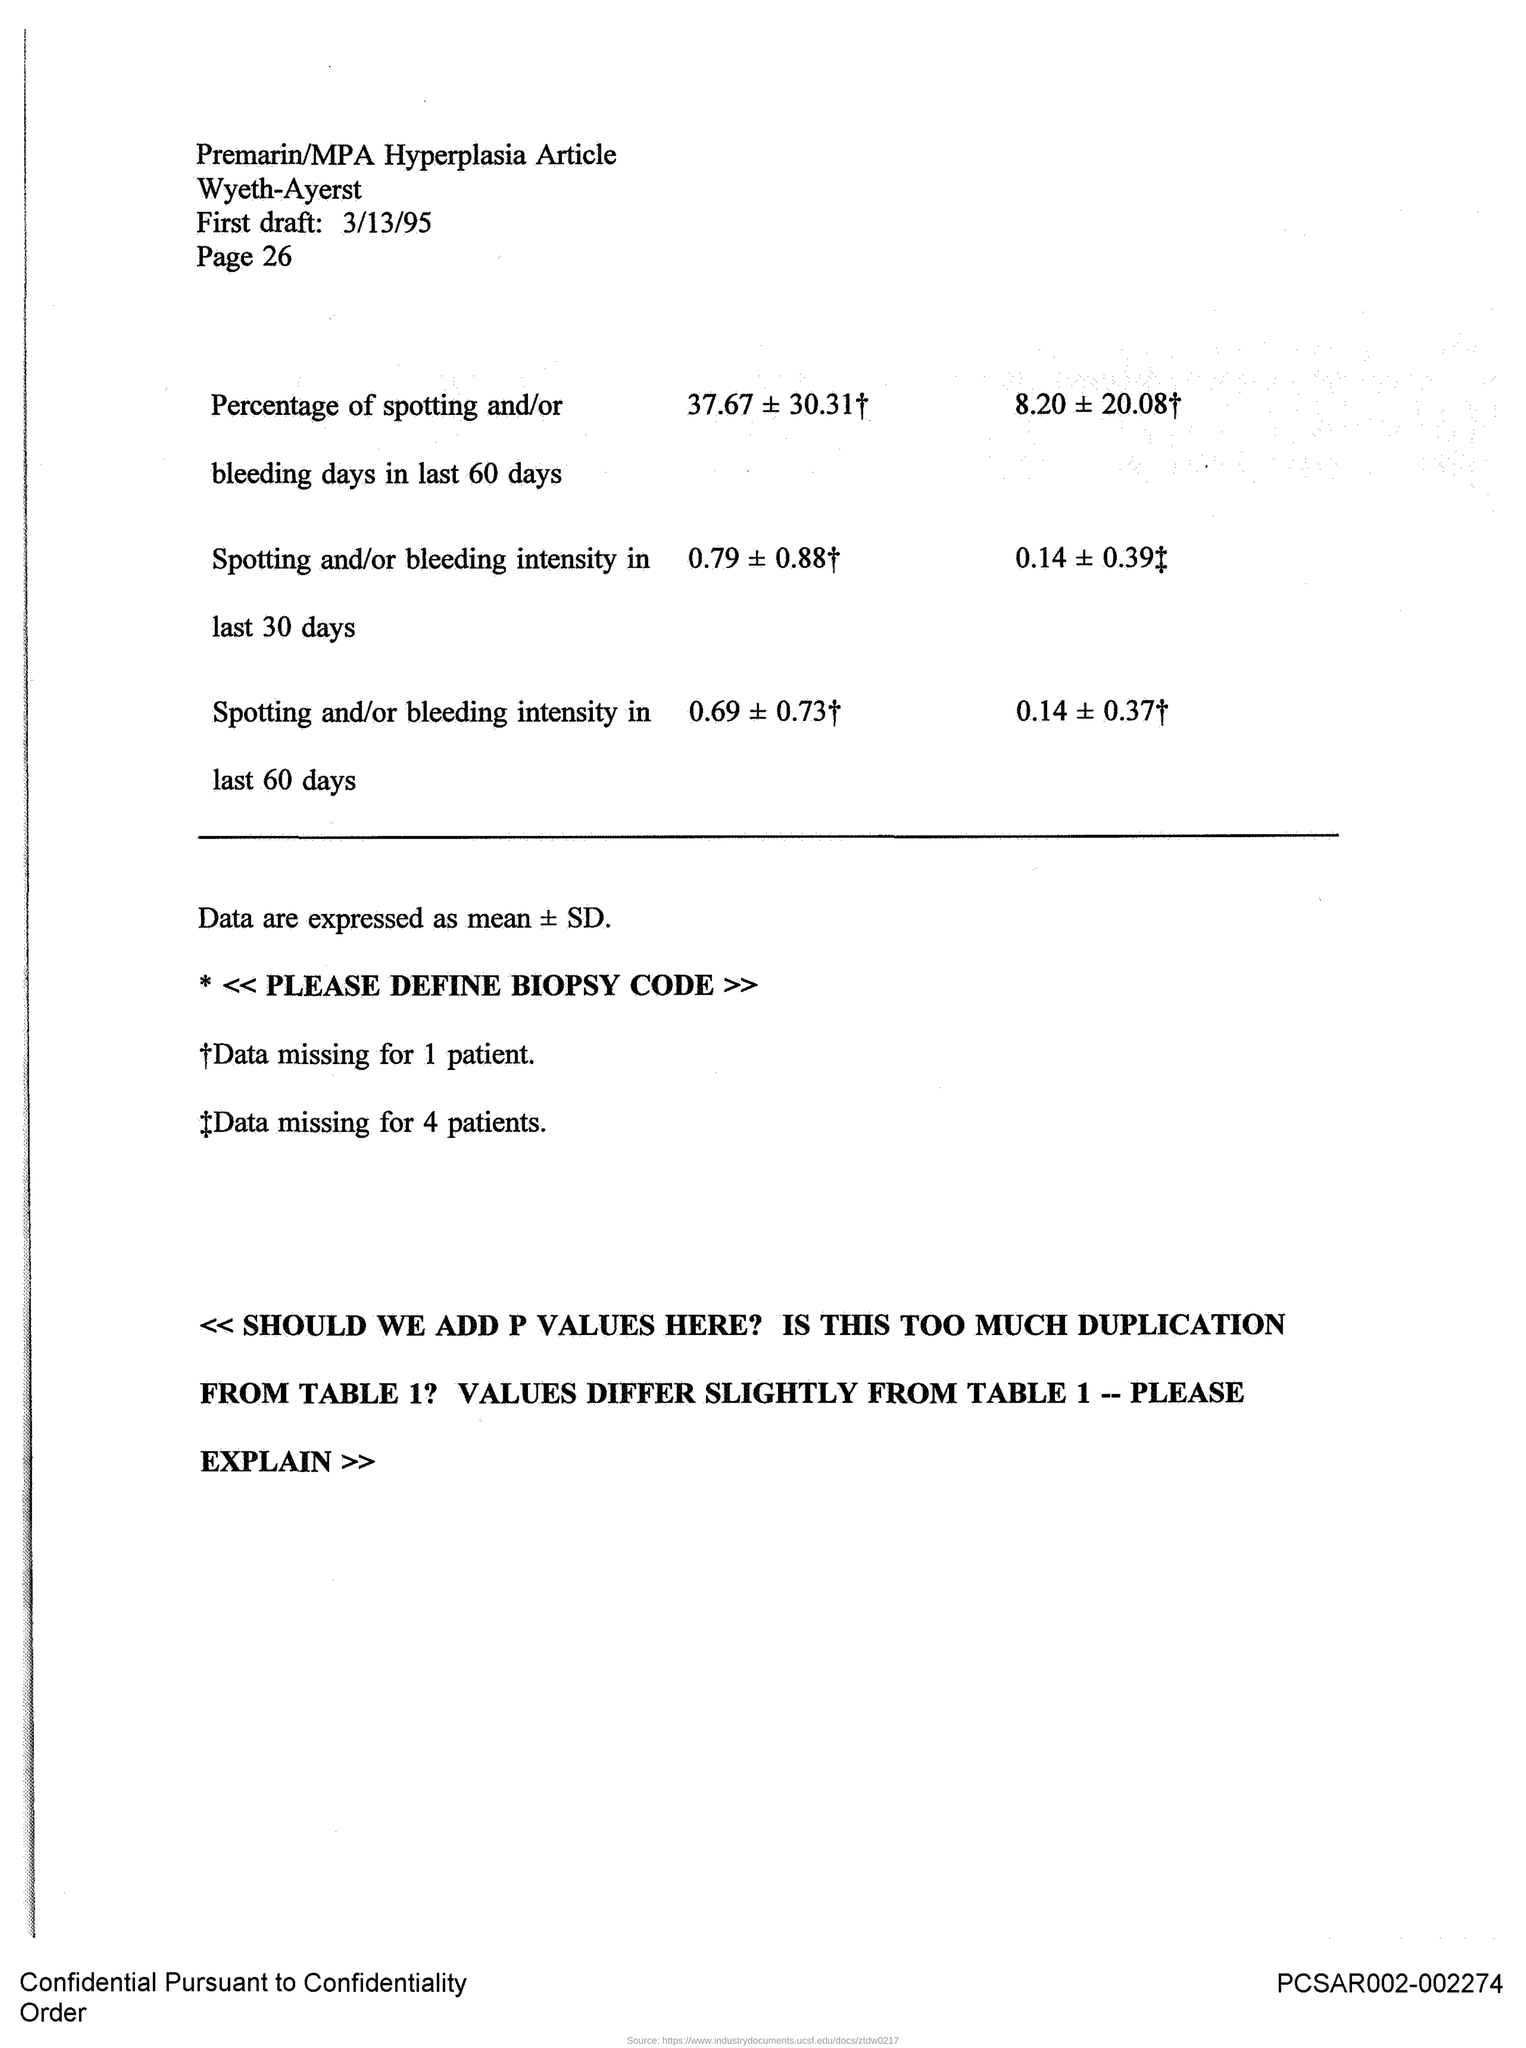When is the first draft?
Offer a terse response. 3/13/95. What is the page?
Provide a succinct answer. PAGE 26. 